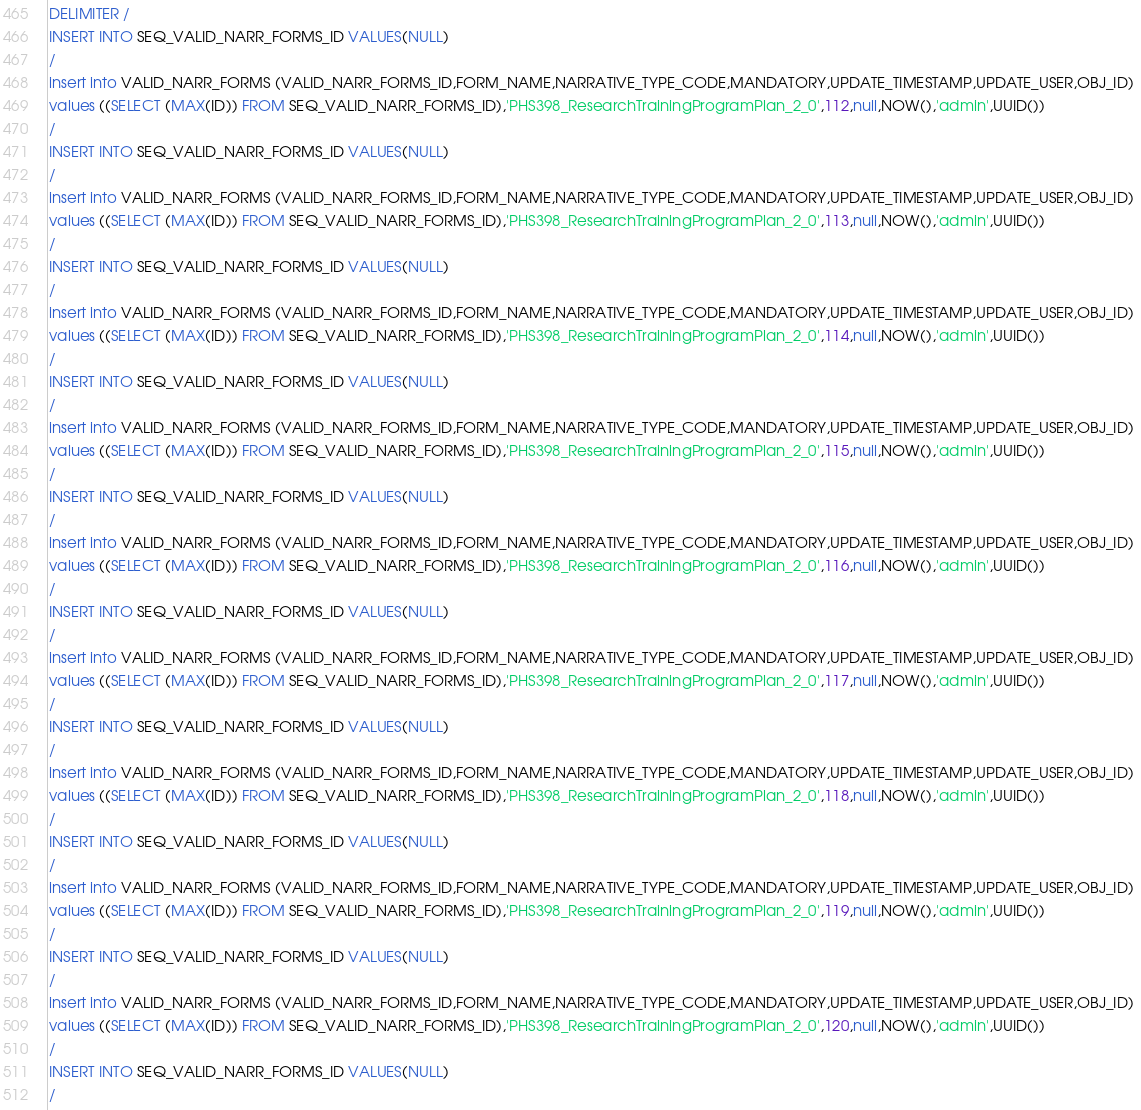<code> <loc_0><loc_0><loc_500><loc_500><_SQL_>DELIMITER /
INSERT INTO SEQ_VALID_NARR_FORMS_ID VALUES(NULL)
/
insert into VALID_NARR_FORMS (VALID_NARR_FORMS_ID,FORM_NAME,NARRATIVE_TYPE_CODE,MANDATORY,UPDATE_TIMESTAMP,UPDATE_USER,OBJ_ID) 
values ((SELECT (MAX(ID)) FROM SEQ_VALID_NARR_FORMS_ID),'PHS398_ResearchTrainingProgramPlan_2_0',112,null,NOW(),'admin',UUID())
/
INSERT INTO SEQ_VALID_NARR_FORMS_ID VALUES(NULL)
/
insert into VALID_NARR_FORMS (VALID_NARR_FORMS_ID,FORM_NAME,NARRATIVE_TYPE_CODE,MANDATORY,UPDATE_TIMESTAMP,UPDATE_USER,OBJ_ID) 
values ((SELECT (MAX(ID)) FROM SEQ_VALID_NARR_FORMS_ID),'PHS398_ResearchTrainingProgramPlan_2_0',113,null,NOW(),'admin',UUID())
/
INSERT INTO SEQ_VALID_NARR_FORMS_ID VALUES(NULL)
/
insert into VALID_NARR_FORMS (VALID_NARR_FORMS_ID,FORM_NAME,NARRATIVE_TYPE_CODE,MANDATORY,UPDATE_TIMESTAMP,UPDATE_USER,OBJ_ID) 
values ((SELECT (MAX(ID)) FROM SEQ_VALID_NARR_FORMS_ID),'PHS398_ResearchTrainingProgramPlan_2_0',114,null,NOW(),'admin',UUID())
/
INSERT INTO SEQ_VALID_NARR_FORMS_ID VALUES(NULL)
/
insert into VALID_NARR_FORMS (VALID_NARR_FORMS_ID,FORM_NAME,NARRATIVE_TYPE_CODE,MANDATORY,UPDATE_TIMESTAMP,UPDATE_USER,OBJ_ID) 
values ((SELECT (MAX(ID)) FROM SEQ_VALID_NARR_FORMS_ID),'PHS398_ResearchTrainingProgramPlan_2_0',115,null,NOW(),'admin',UUID())
/
INSERT INTO SEQ_VALID_NARR_FORMS_ID VALUES(NULL)
/
insert into VALID_NARR_FORMS (VALID_NARR_FORMS_ID,FORM_NAME,NARRATIVE_TYPE_CODE,MANDATORY,UPDATE_TIMESTAMP,UPDATE_USER,OBJ_ID) 
values ((SELECT (MAX(ID)) FROM SEQ_VALID_NARR_FORMS_ID),'PHS398_ResearchTrainingProgramPlan_2_0',116,null,NOW(),'admin',UUID())
/
INSERT INTO SEQ_VALID_NARR_FORMS_ID VALUES(NULL)
/
insert into VALID_NARR_FORMS (VALID_NARR_FORMS_ID,FORM_NAME,NARRATIVE_TYPE_CODE,MANDATORY,UPDATE_TIMESTAMP,UPDATE_USER,OBJ_ID) 
values ((SELECT (MAX(ID)) FROM SEQ_VALID_NARR_FORMS_ID),'PHS398_ResearchTrainingProgramPlan_2_0',117,null,NOW(),'admin',UUID())
/
INSERT INTO SEQ_VALID_NARR_FORMS_ID VALUES(NULL)
/
insert into VALID_NARR_FORMS (VALID_NARR_FORMS_ID,FORM_NAME,NARRATIVE_TYPE_CODE,MANDATORY,UPDATE_TIMESTAMP,UPDATE_USER,OBJ_ID) 
values ((SELECT (MAX(ID)) FROM SEQ_VALID_NARR_FORMS_ID),'PHS398_ResearchTrainingProgramPlan_2_0',118,null,NOW(),'admin',UUID())
/
INSERT INTO SEQ_VALID_NARR_FORMS_ID VALUES(NULL)
/
insert into VALID_NARR_FORMS (VALID_NARR_FORMS_ID,FORM_NAME,NARRATIVE_TYPE_CODE,MANDATORY,UPDATE_TIMESTAMP,UPDATE_USER,OBJ_ID) 
values ((SELECT (MAX(ID)) FROM SEQ_VALID_NARR_FORMS_ID),'PHS398_ResearchTrainingProgramPlan_2_0',119,null,NOW(),'admin',UUID())
/
INSERT INTO SEQ_VALID_NARR_FORMS_ID VALUES(NULL)
/
insert into VALID_NARR_FORMS (VALID_NARR_FORMS_ID,FORM_NAME,NARRATIVE_TYPE_CODE,MANDATORY,UPDATE_TIMESTAMP,UPDATE_USER,OBJ_ID) 
values ((SELECT (MAX(ID)) FROM SEQ_VALID_NARR_FORMS_ID),'PHS398_ResearchTrainingProgramPlan_2_0',120,null,NOW(),'admin',UUID())
/
INSERT INTO SEQ_VALID_NARR_FORMS_ID VALUES(NULL)
/</code> 